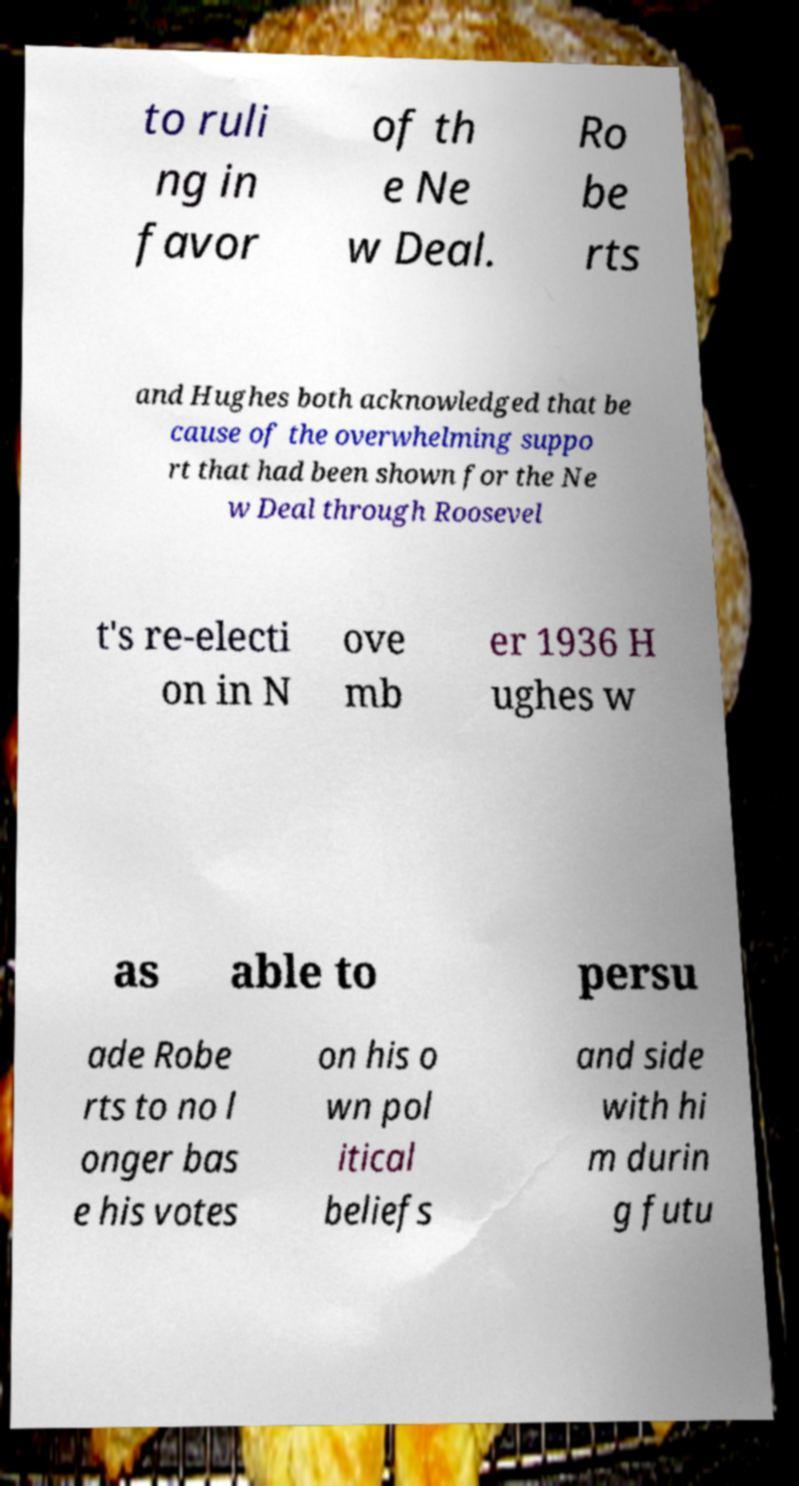For documentation purposes, I need the text within this image transcribed. Could you provide that? to ruli ng in favor of th e Ne w Deal. Ro be rts and Hughes both acknowledged that be cause of the overwhelming suppo rt that had been shown for the Ne w Deal through Roosevel t's re-electi on in N ove mb er 1936 H ughes w as able to persu ade Robe rts to no l onger bas e his votes on his o wn pol itical beliefs and side with hi m durin g futu 